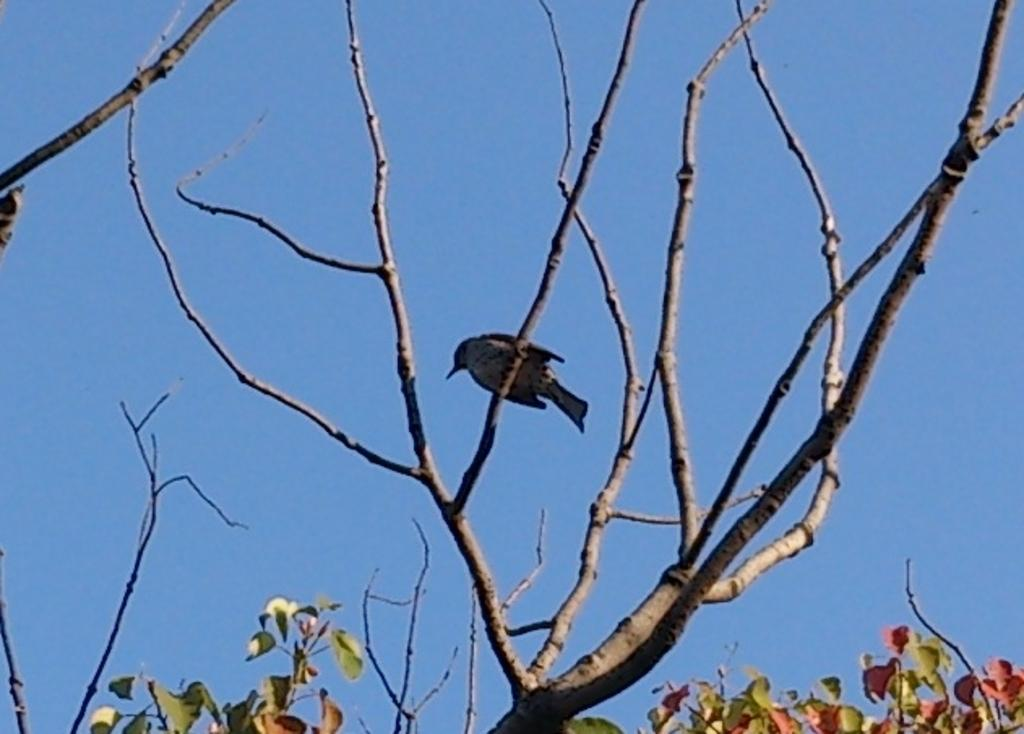What type of animal can be seen in the image? There is a bird in the image. Where is the bird located? The bird is on a tree branch. What else can be seen on the tree in the image? Leaves are visible in the image. What is visible in the background of the image? The sky is visible in the background of the image. What type of jam is the bird spreading on the basketball in the image? There is no jam or basketball present in the image; it features a bird on a tree branch with leaves and a visible sky in the background. 